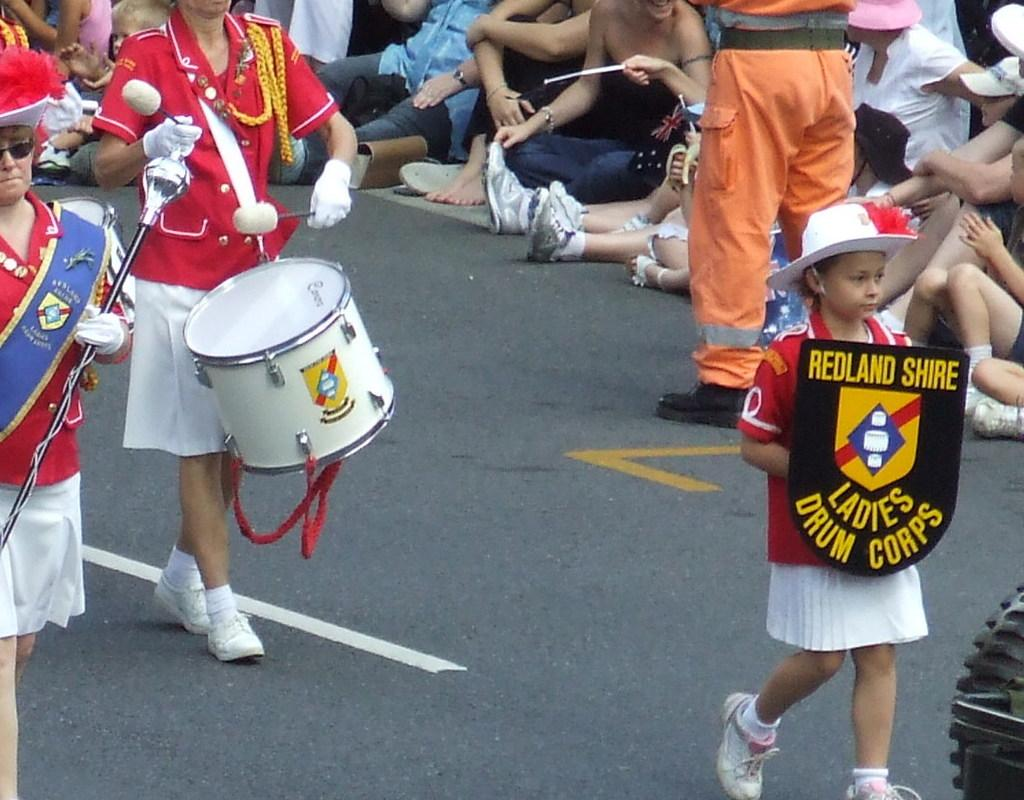<image>
Provide a brief description of the given image. A child holds a sign that says Redland Shire Ladis Drump Corps in a parade. 